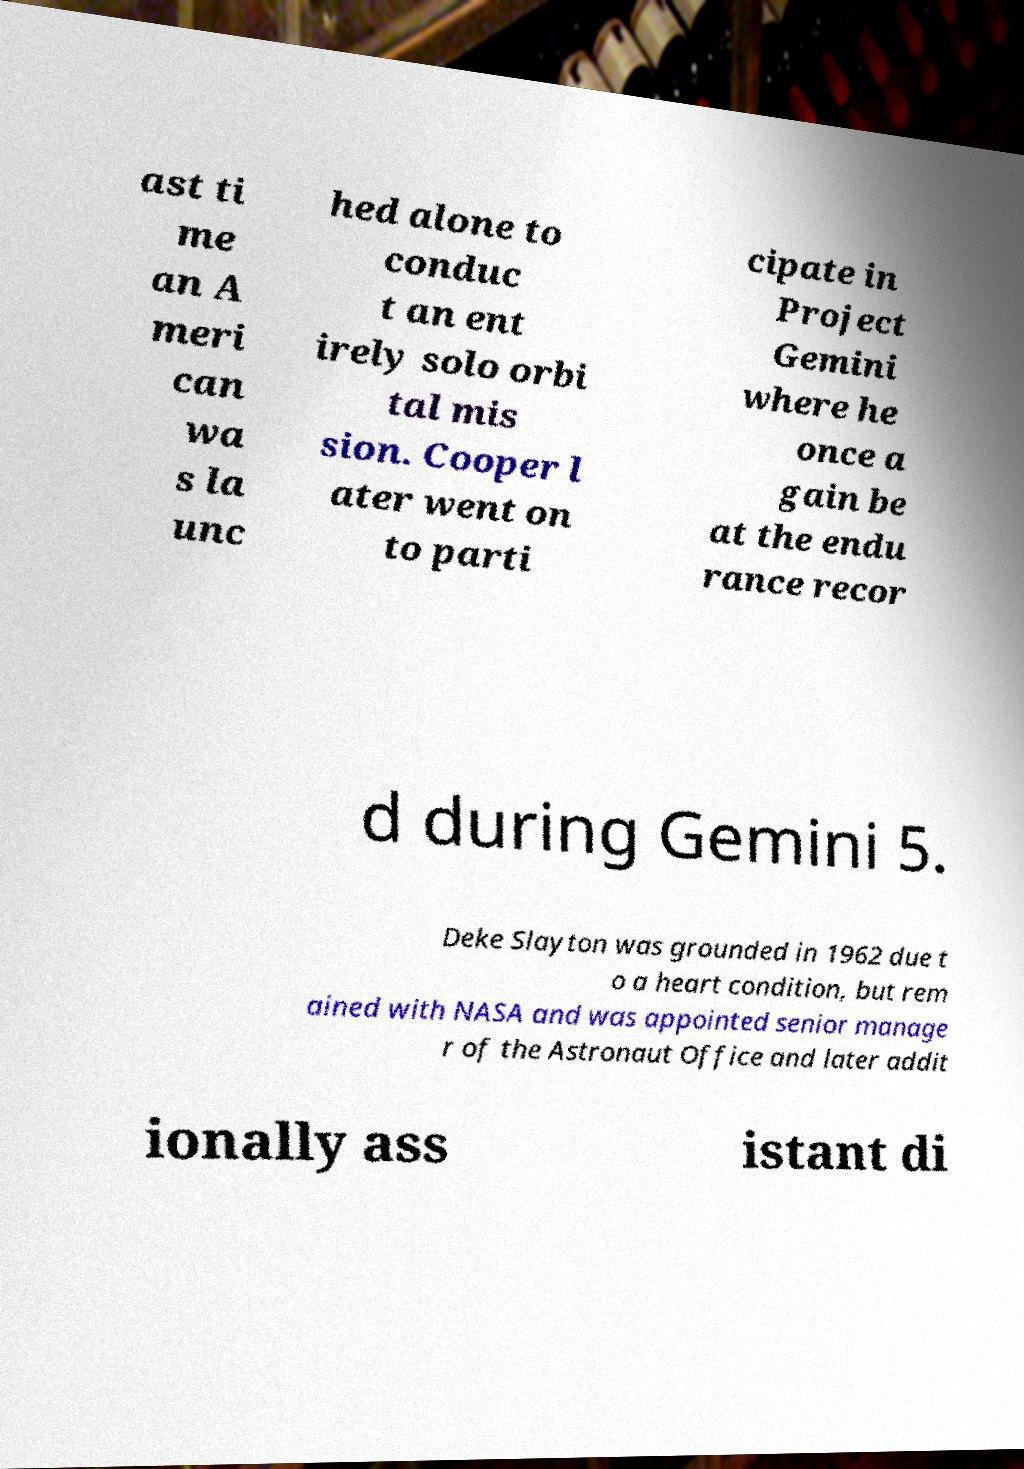Could you assist in decoding the text presented in this image and type it out clearly? ast ti me an A meri can wa s la unc hed alone to conduc t an ent irely solo orbi tal mis sion. Cooper l ater went on to parti cipate in Project Gemini where he once a gain be at the endu rance recor d during Gemini 5. Deke Slayton was grounded in 1962 due t o a heart condition, but rem ained with NASA and was appointed senior manage r of the Astronaut Office and later addit ionally ass istant di 